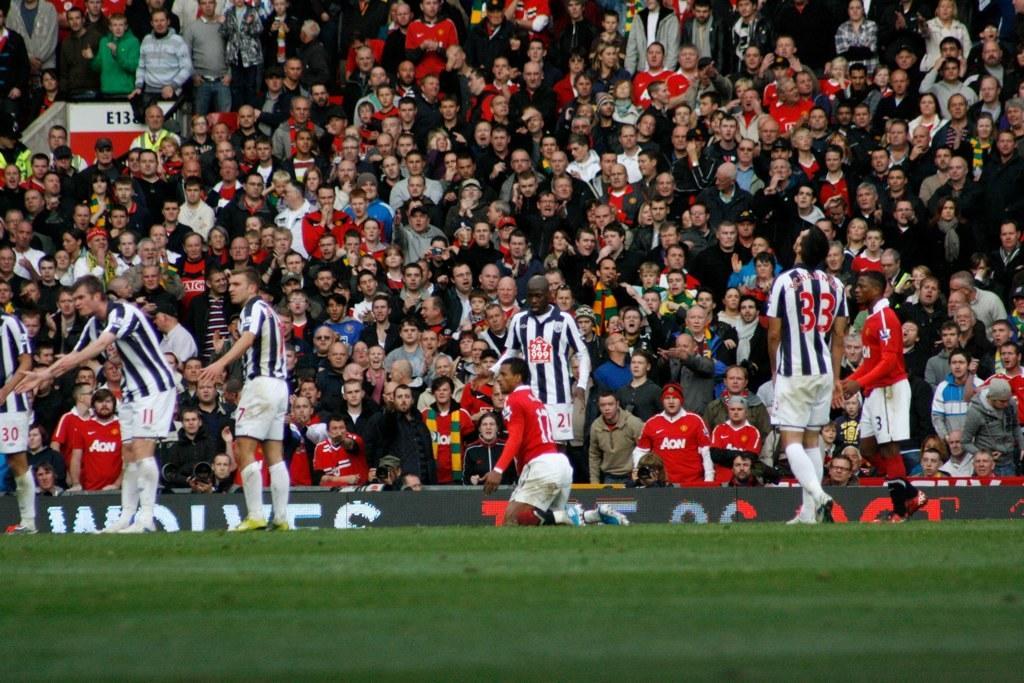In one or two sentences, can you explain what this image depicts? In this image there are so many players standing in the ground, beside them there are so many other people standing and sitting in stadium and watching at them. 